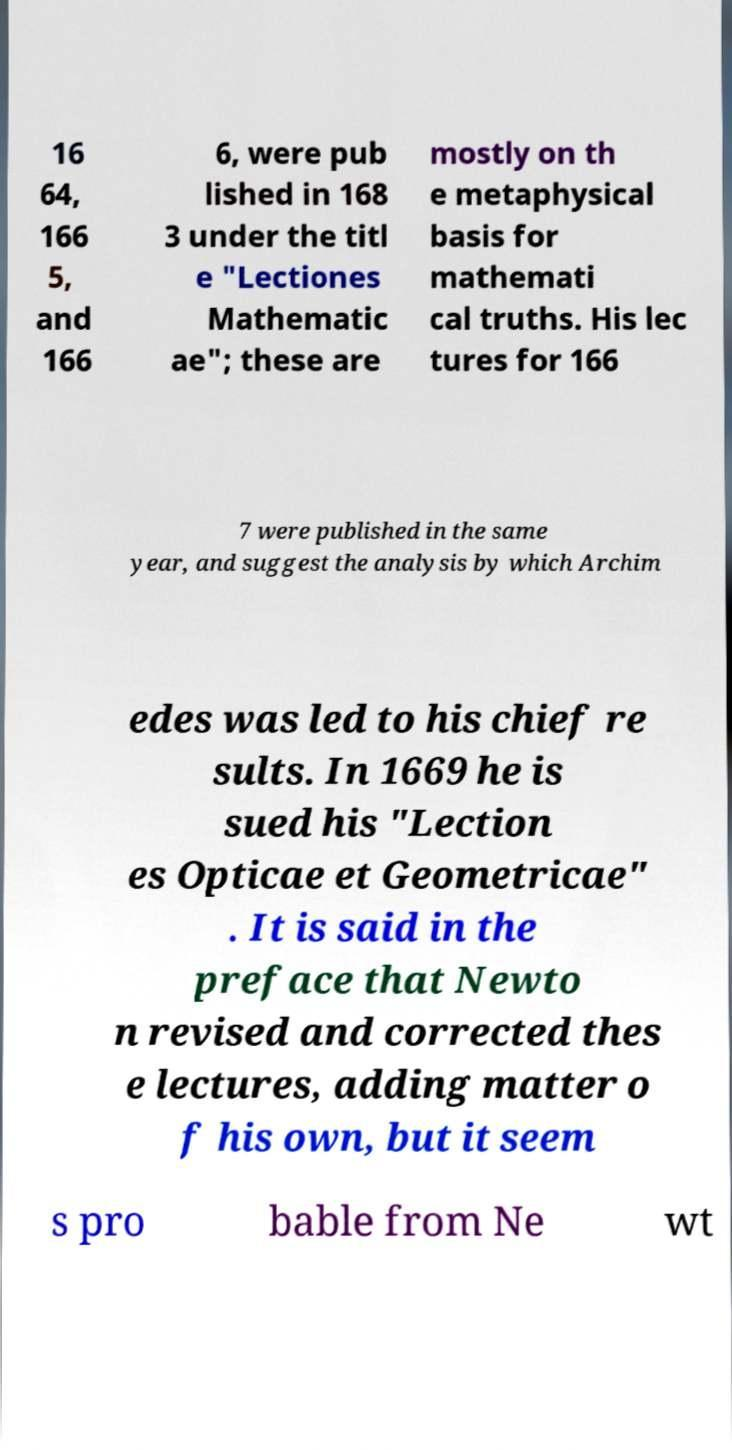Please read and relay the text visible in this image. What does it say? 16 64, 166 5, and 166 6, were pub lished in 168 3 under the titl e "Lectiones Mathematic ae"; these are mostly on th e metaphysical basis for mathemati cal truths. His lec tures for 166 7 were published in the same year, and suggest the analysis by which Archim edes was led to his chief re sults. In 1669 he is sued his "Lection es Opticae et Geometricae" . It is said in the preface that Newto n revised and corrected thes e lectures, adding matter o f his own, but it seem s pro bable from Ne wt 